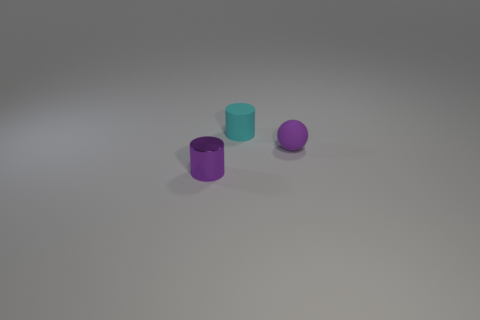Do the tiny purple rubber thing and the cyan matte thing have the same shape?
Make the answer very short. No. Is there a tiny purple metallic object to the left of the purple object in front of the tiny purple thing to the right of the cyan cylinder?
Keep it short and to the point. No. How many cylinders are the same color as the ball?
Give a very brief answer. 1. The other purple object that is the same size as the purple rubber thing is what shape?
Your response must be concise. Cylinder. Are there any matte things in front of the small purple ball?
Provide a short and direct response. No. Do the purple shiny cylinder and the ball have the same size?
Make the answer very short. Yes. What shape is the tiny purple object on the right side of the tiny cyan cylinder?
Offer a very short reply. Sphere. Is there a purple thing of the same size as the cyan object?
Offer a very short reply. Yes. There is a purple cylinder that is the same size as the sphere; what is it made of?
Offer a very short reply. Metal. There is a cylinder that is to the right of the small purple cylinder; what is its size?
Give a very brief answer. Small. 